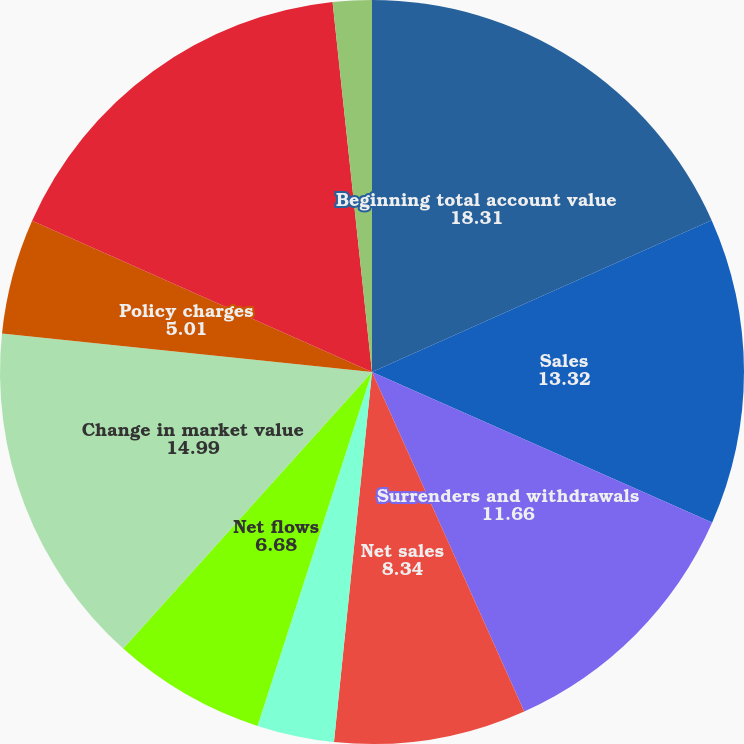<chart> <loc_0><loc_0><loc_500><loc_500><pie_chart><fcel>Beginning total account value<fcel>Sales<fcel>Surrenders and withdrawals<fcel>Net sales<fcel>Benefit Payments<fcel>Net flows<fcel>Change in market value<fcel>Policy charges<fcel>Ending total account value(3)<fcel>Net redemptions<nl><fcel>18.31%<fcel>13.32%<fcel>11.66%<fcel>8.34%<fcel>3.35%<fcel>6.68%<fcel>14.99%<fcel>5.01%<fcel>16.65%<fcel>1.69%<nl></chart> 